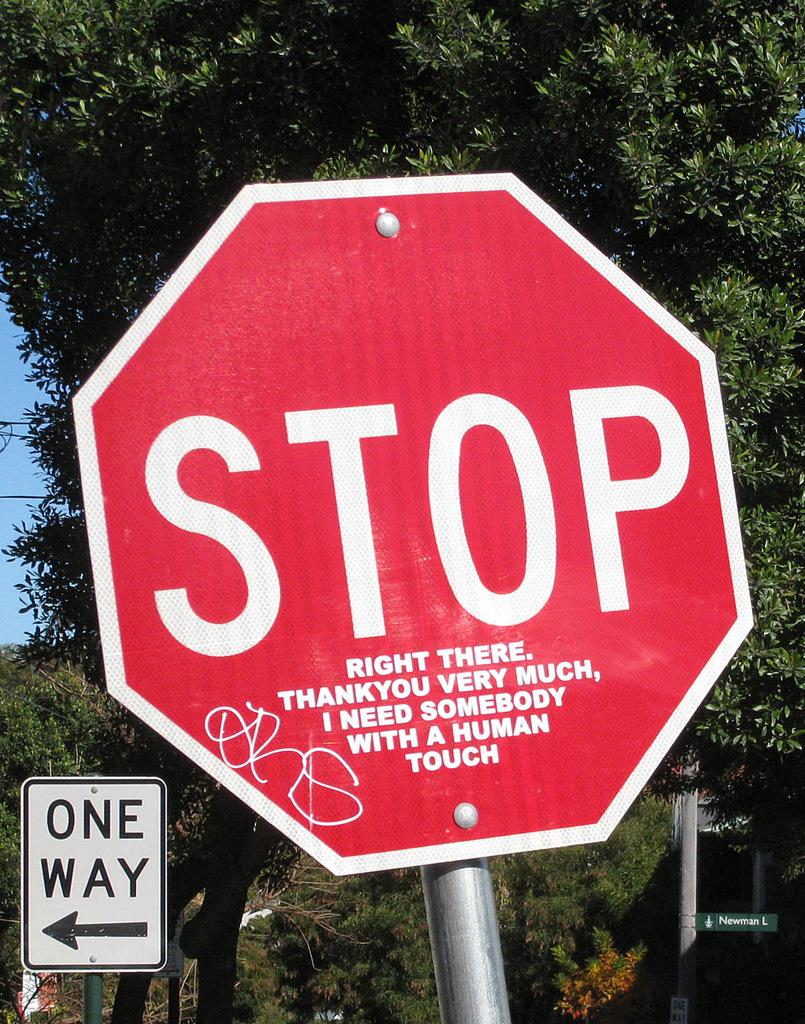<image>
Summarize the visual content of the image. a stop sign that is red and white in color near a one way 